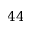<formula> <loc_0><loc_0><loc_500><loc_500>4 4</formula> 